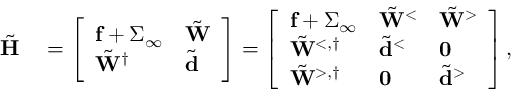Convert formula to latex. <formula><loc_0><loc_0><loc_500><loc_500>\begin{array} { r l } { \tilde { H } } & = \left [ \begin{array} { l l } { f + \Sigma _ { \infty } } & { \tilde { W } } \\ { \tilde { W } ^ { \dagger } } & { \tilde { d } } \end{array} \right ] = \left [ \begin{array} { l l l } { f + \Sigma _ { \infty } } & { \tilde { W } ^ { < } } & { \tilde { W } ^ { > } } \\ { \tilde { W } ^ { < , \dagger } } & { \tilde { d } ^ { < } } & { 0 } \\ { \tilde { W } ^ { > , \dagger } } & { 0 } & { \tilde { d } ^ { > } } \end{array} \right ] , } \end{array}</formula> 